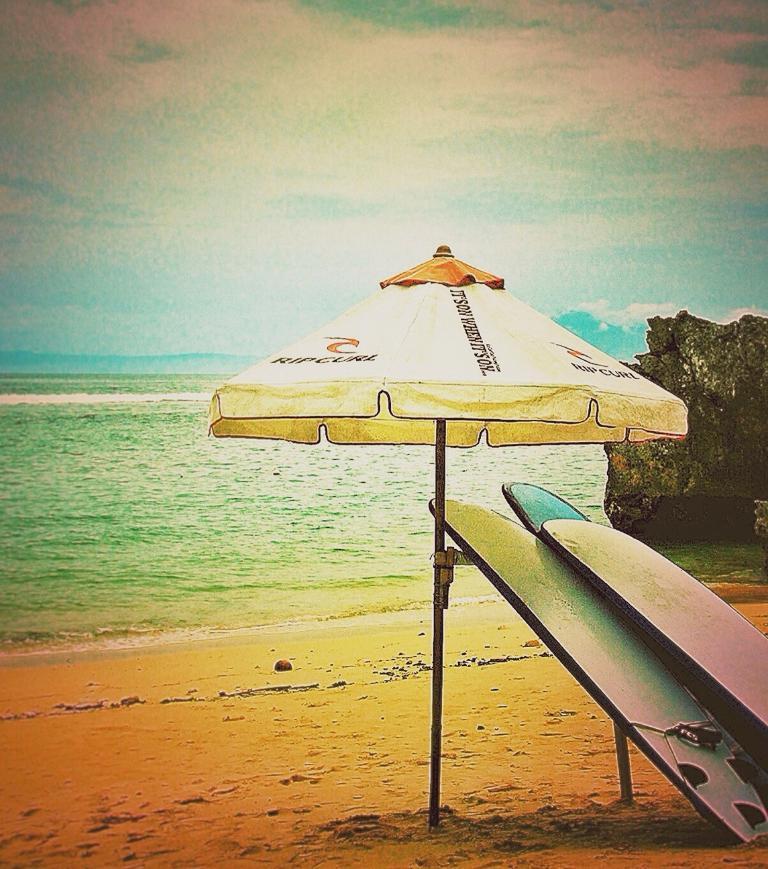How would you summarize this image in a sentence or two? In this image I can see the umbrella, few surfboards, sand, water, rock and the sky. 